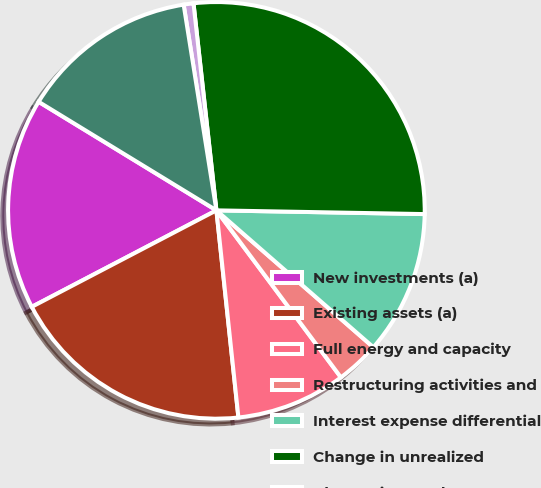<chart> <loc_0><loc_0><loc_500><loc_500><pie_chart><fcel>New investments (a)<fcel>Existing assets (a)<fcel>Full energy and capacity<fcel>Restructuring activities and<fcel>Interest expense differential<fcel>Change in unrealized<fcel>Change in OTTI losses on<fcel>Net income increase (decrease)<nl><fcel>16.39%<fcel>19.02%<fcel>8.51%<fcel>3.39%<fcel>11.13%<fcel>27.04%<fcel>0.76%<fcel>13.76%<nl></chart> 